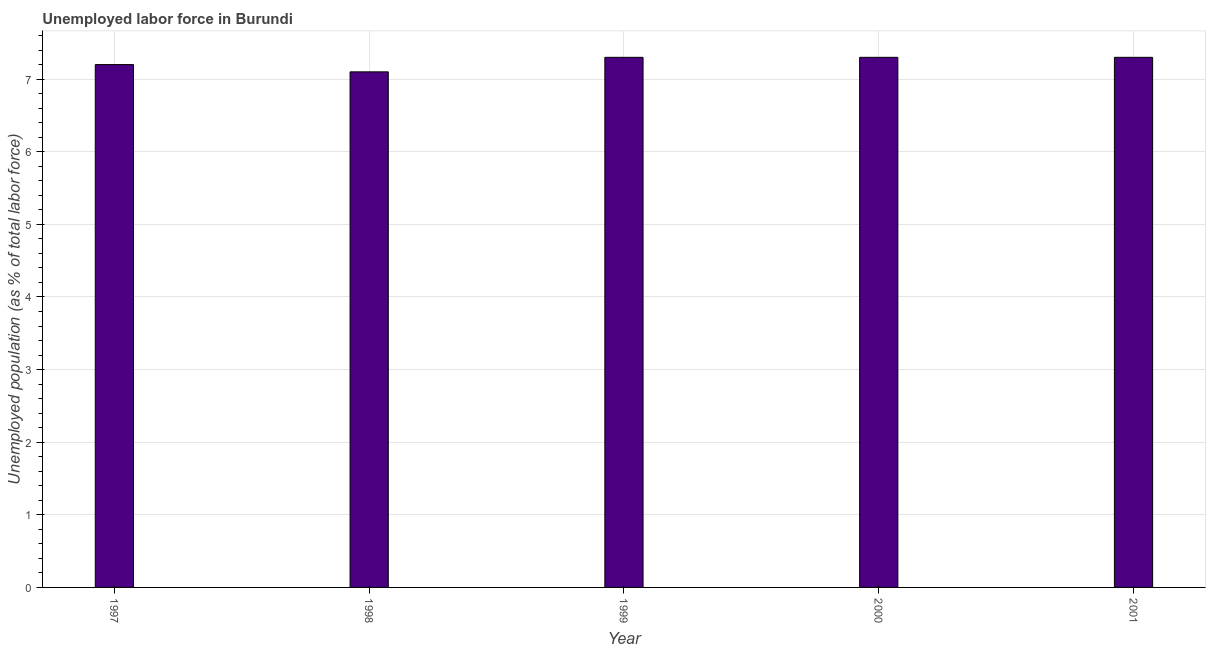Does the graph contain grids?
Offer a terse response. Yes. What is the title of the graph?
Provide a succinct answer. Unemployed labor force in Burundi. What is the label or title of the Y-axis?
Your response must be concise. Unemployed population (as % of total labor force). What is the total unemployed population in 1998?
Provide a succinct answer. 7.1. Across all years, what is the maximum total unemployed population?
Your answer should be compact. 7.3. Across all years, what is the minimum total unemployed population?
Your answer should be compact. 7.1. In which year was the total unemployed population minimum?
Your response must be concise. 1998. What is the sum of the total unemployed population?
Ensure brevity in your answer.  36.2. What is the difference between the total unemployed population in 1999 and 2000?
Keep it short and to the point. 0. What is the average total unemployed population per year?
Your answer should be compact. 7.24. What is the median total unemployed population?
Provide a succinct answer. 7.3. What is the ratio of the total unemployed population in 1998 to that in 1999?
Offer a very short reply. 0.97. Is the difference between the total unemployed population in 1997 and 1998 greater than the difference between any two years?
Offer a very short reply. No. What is the difference between the highest and the second highest total unemployed population?
Your answer should be compact. 0. In how many years, is the total unemployed population greater than the average total unemployed population taken over all years?
Ensure brevity in your answer.  3. How many bars are there?
Your answer should be compact. 5. How many years are there in the graph?
Your answer should be very brief. 5. Are the values on the major ticks of Y-axis written in scientific E-notation?
Your answer should be very brief. No. What is the Unemployed population (as % of total labor force) of 1997?
Your response must be concise. 7.2. What is the Unemployed population (as % of total labor force) in 1998?
Offer a very short reply. 7.1. What is the Unemployed population (as % of total labor force) of 1999?
Provide a short and direct response. 7.3. What is the Unemployed population (as % of total labor force) in 2000?
Give a very brief answer. 7.3. What is the Unemployed population (as % of total labor force) of 2001?
Your answer should be compact. 7.3. What is the difference between the Unemployed population (as % of total labor force) in 1997 and 2001?
Ensure brevity in your answer.  -0.1. What is the difference between the Unemployed population (as % of total labor force) in 1998 and 1999?
Your answer should be compact. -0.2. What is the difference between the Unemployed population (as % of total labor force) in 1999 and 2001?
Offer a very short reply. 0. What is the difference between the Unemployed population (as % of total labor force) in 2000 and 2001?
Offer a very short reply. 0. What is the ratio of the Unemployed population (as % of total labor force) in 1997 to that in 1998?
Your answer should be very brief. 1.01. What is the ratio of the Unemployed population (as % of total labor force) in 1998 to that in 1999?
Keep it short and to the point. 0.97. What is the ratio of the Unemployed population (as % of total labor force) in 1998 to that in 2001?
Your answer should be very brief. 0.97. What is the ratio of the Unemployed population (as % of total labor force) in 1999 to that in 2001?
Provide a succinct answer. 1. What is the ratio of the Unemployed population (as % of total labor force) in 2000 to that in 2001?
Your response must be concise. 1. 